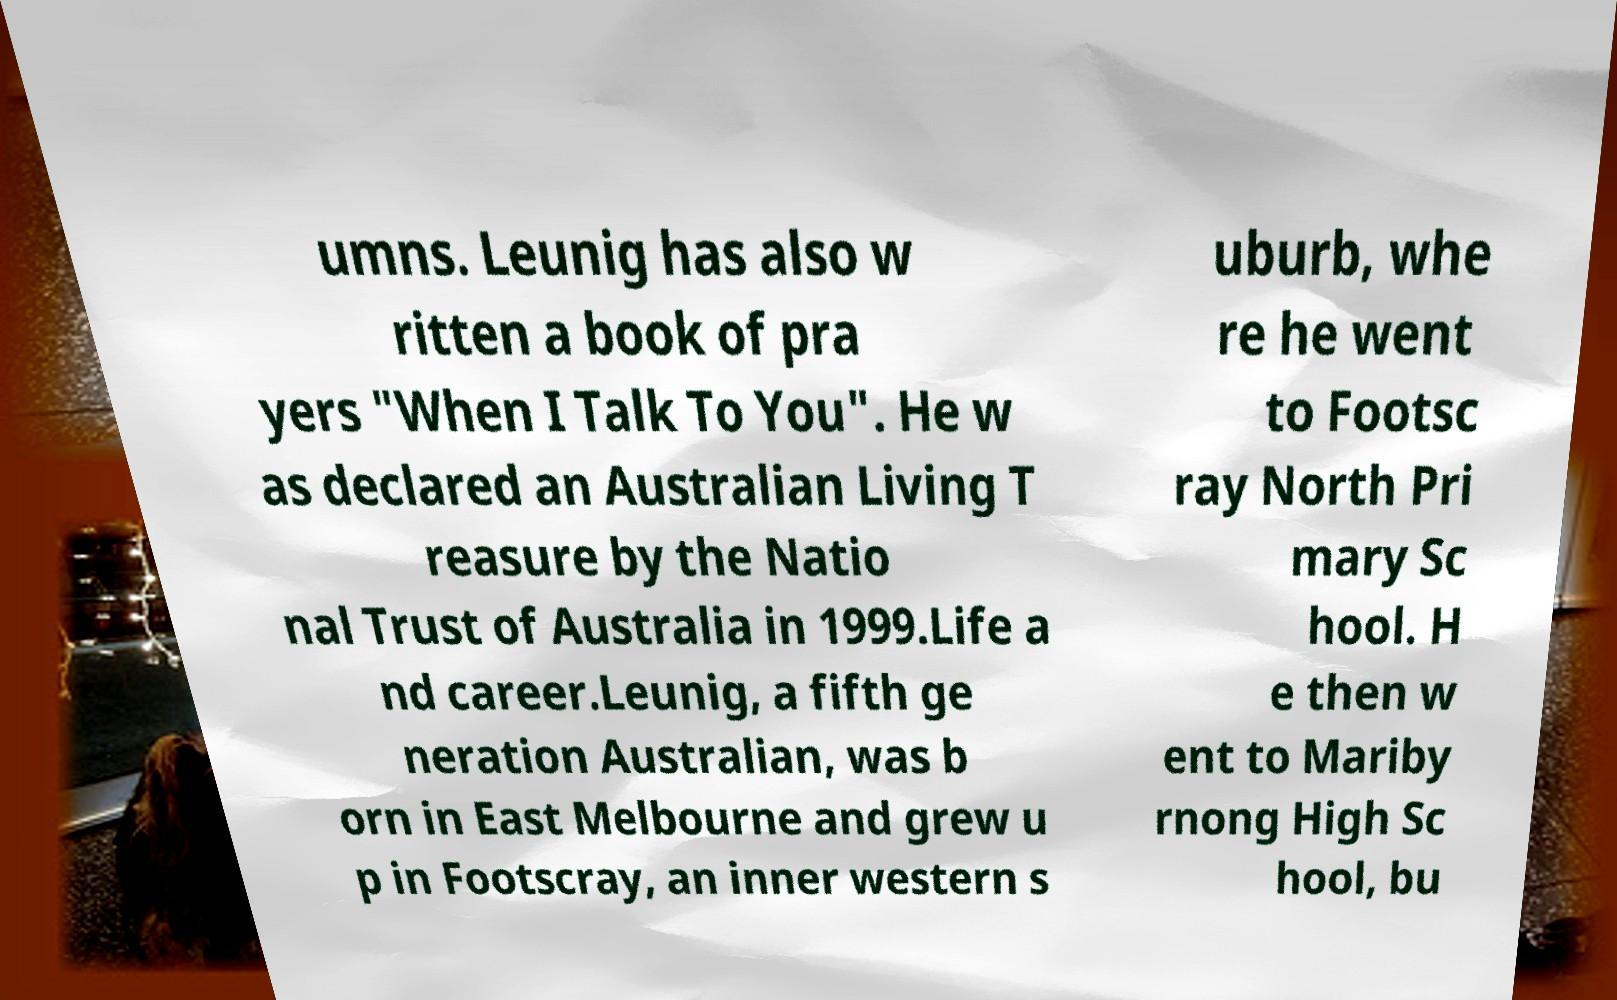Could you assist in decoding the text presented in this image and type it out clearly? umns. Leunig has also w ritten a book of pra yers "When I Talk To You". He w as declared an Australian Living T reasure by the Natio nal Trust of Australia in 1999.Life a nd career.Leunig, a fifth ge neration Australian, was b orn in East Melbourne and grew u p in Footscray, an inner western s uburb, whe re he went to Footsc ray North Pri mary Sc hool. H e then w ent to Mariby rnong High Sc hool, bu 